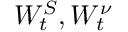<formula> <loc_0><loc_0><loc_500><loc_500>W _ { t } ^ { S } , W _ { t } ^ { \nu }</formula> 